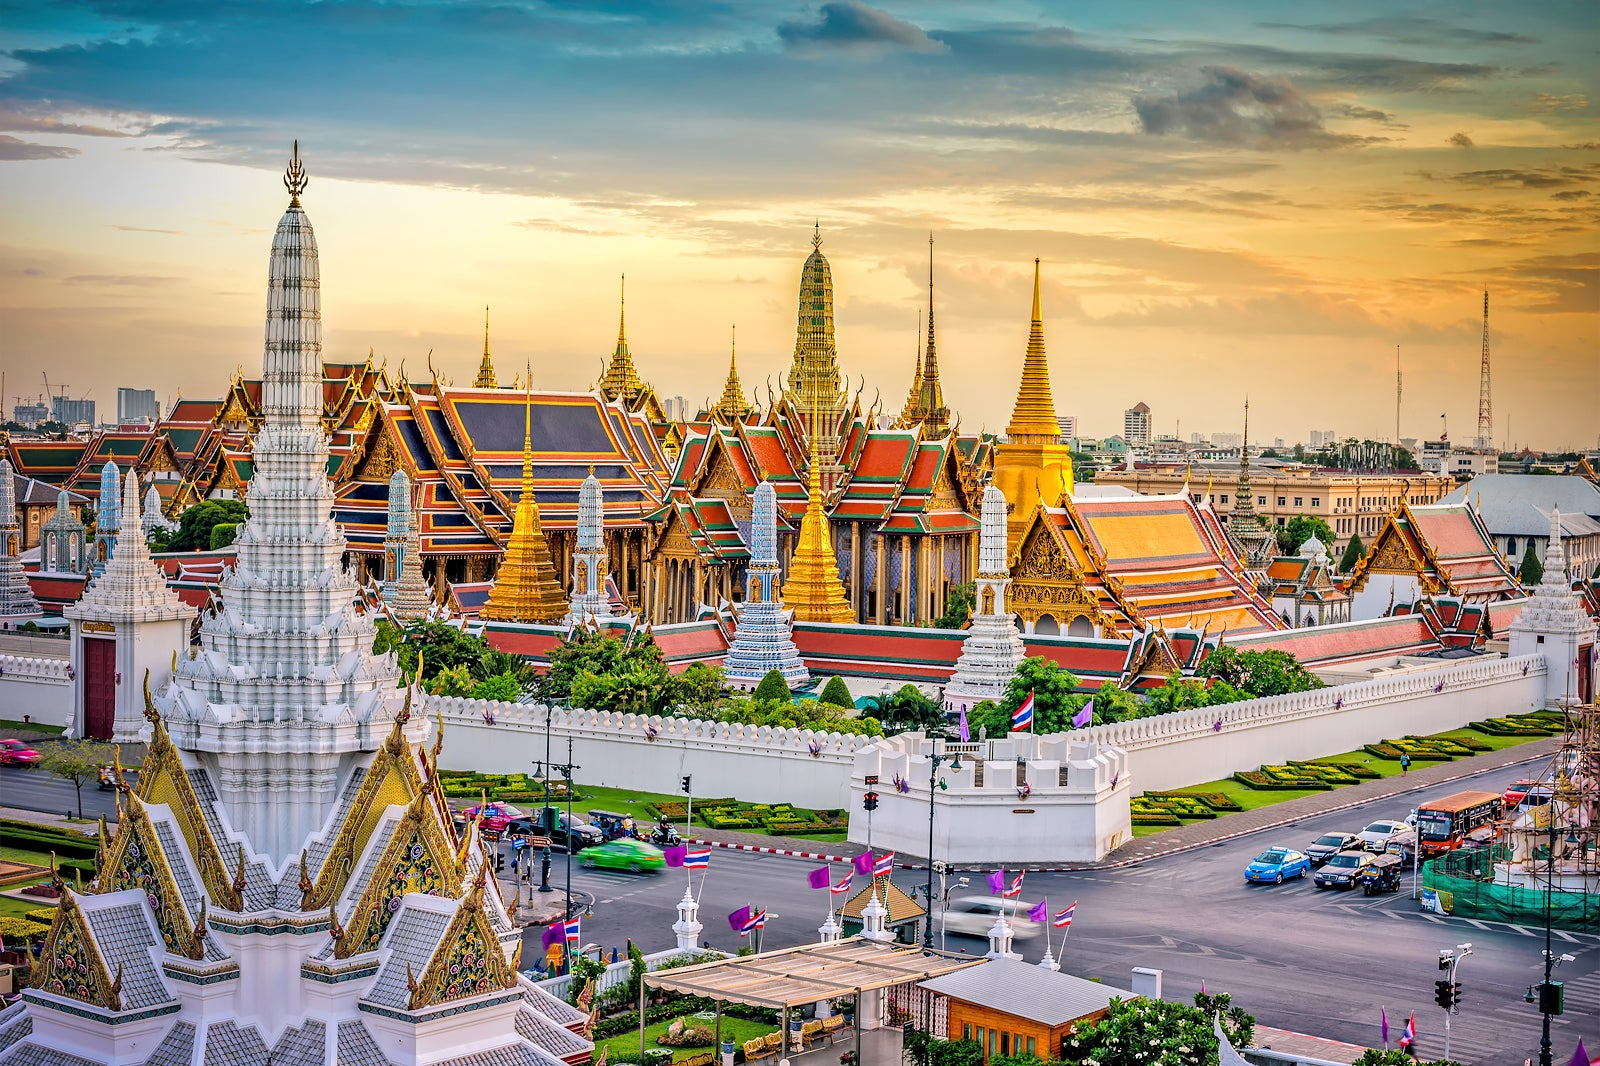How would you describe the architectural style of the Grand Palace? The architectural style of the Grand Palace in Bangkok is a stunning combination of traditional Thai and Western influences. The roofs of the buildings are steeply pitched and adorned with colored glass mosaics and gilded ornaments, typical of Thai architecture. The intricate detailing on the eaves, spires, and pagodas, with their pointed shapes and elaborate decorations, highlights the exquisite craftsmanship. Additionally, elements of European neoclassical architecture are visible, a testament to the palace’s evolution over time. This blend of styles results in a unique and magnificent architectural masterpiece. Can you describe a typical day for visitors at the Grand Palace? Certainly! A typical day for visitors at the Grand Palace begins early to avoid the midday heat and crowds. As they enter through the main gate, they are struck by the immaculate architecture and lush gardens. Guided tours are popular, where knowledgeable guides share fascinating tales and historical tidbits about the various buildings, such as the Emerald Buddha Temple and the Chakri Maha Prasat Hall. Visitors often spend hours marveling at the intricate details, taking photographs, and enjoying the serene atmosphere. Before leaving, many stop by the palace's museum and shops to buy souvenirs. The experience is both educational and awe-inspiring, providing a deep appreciation for Thailand's heritage. 